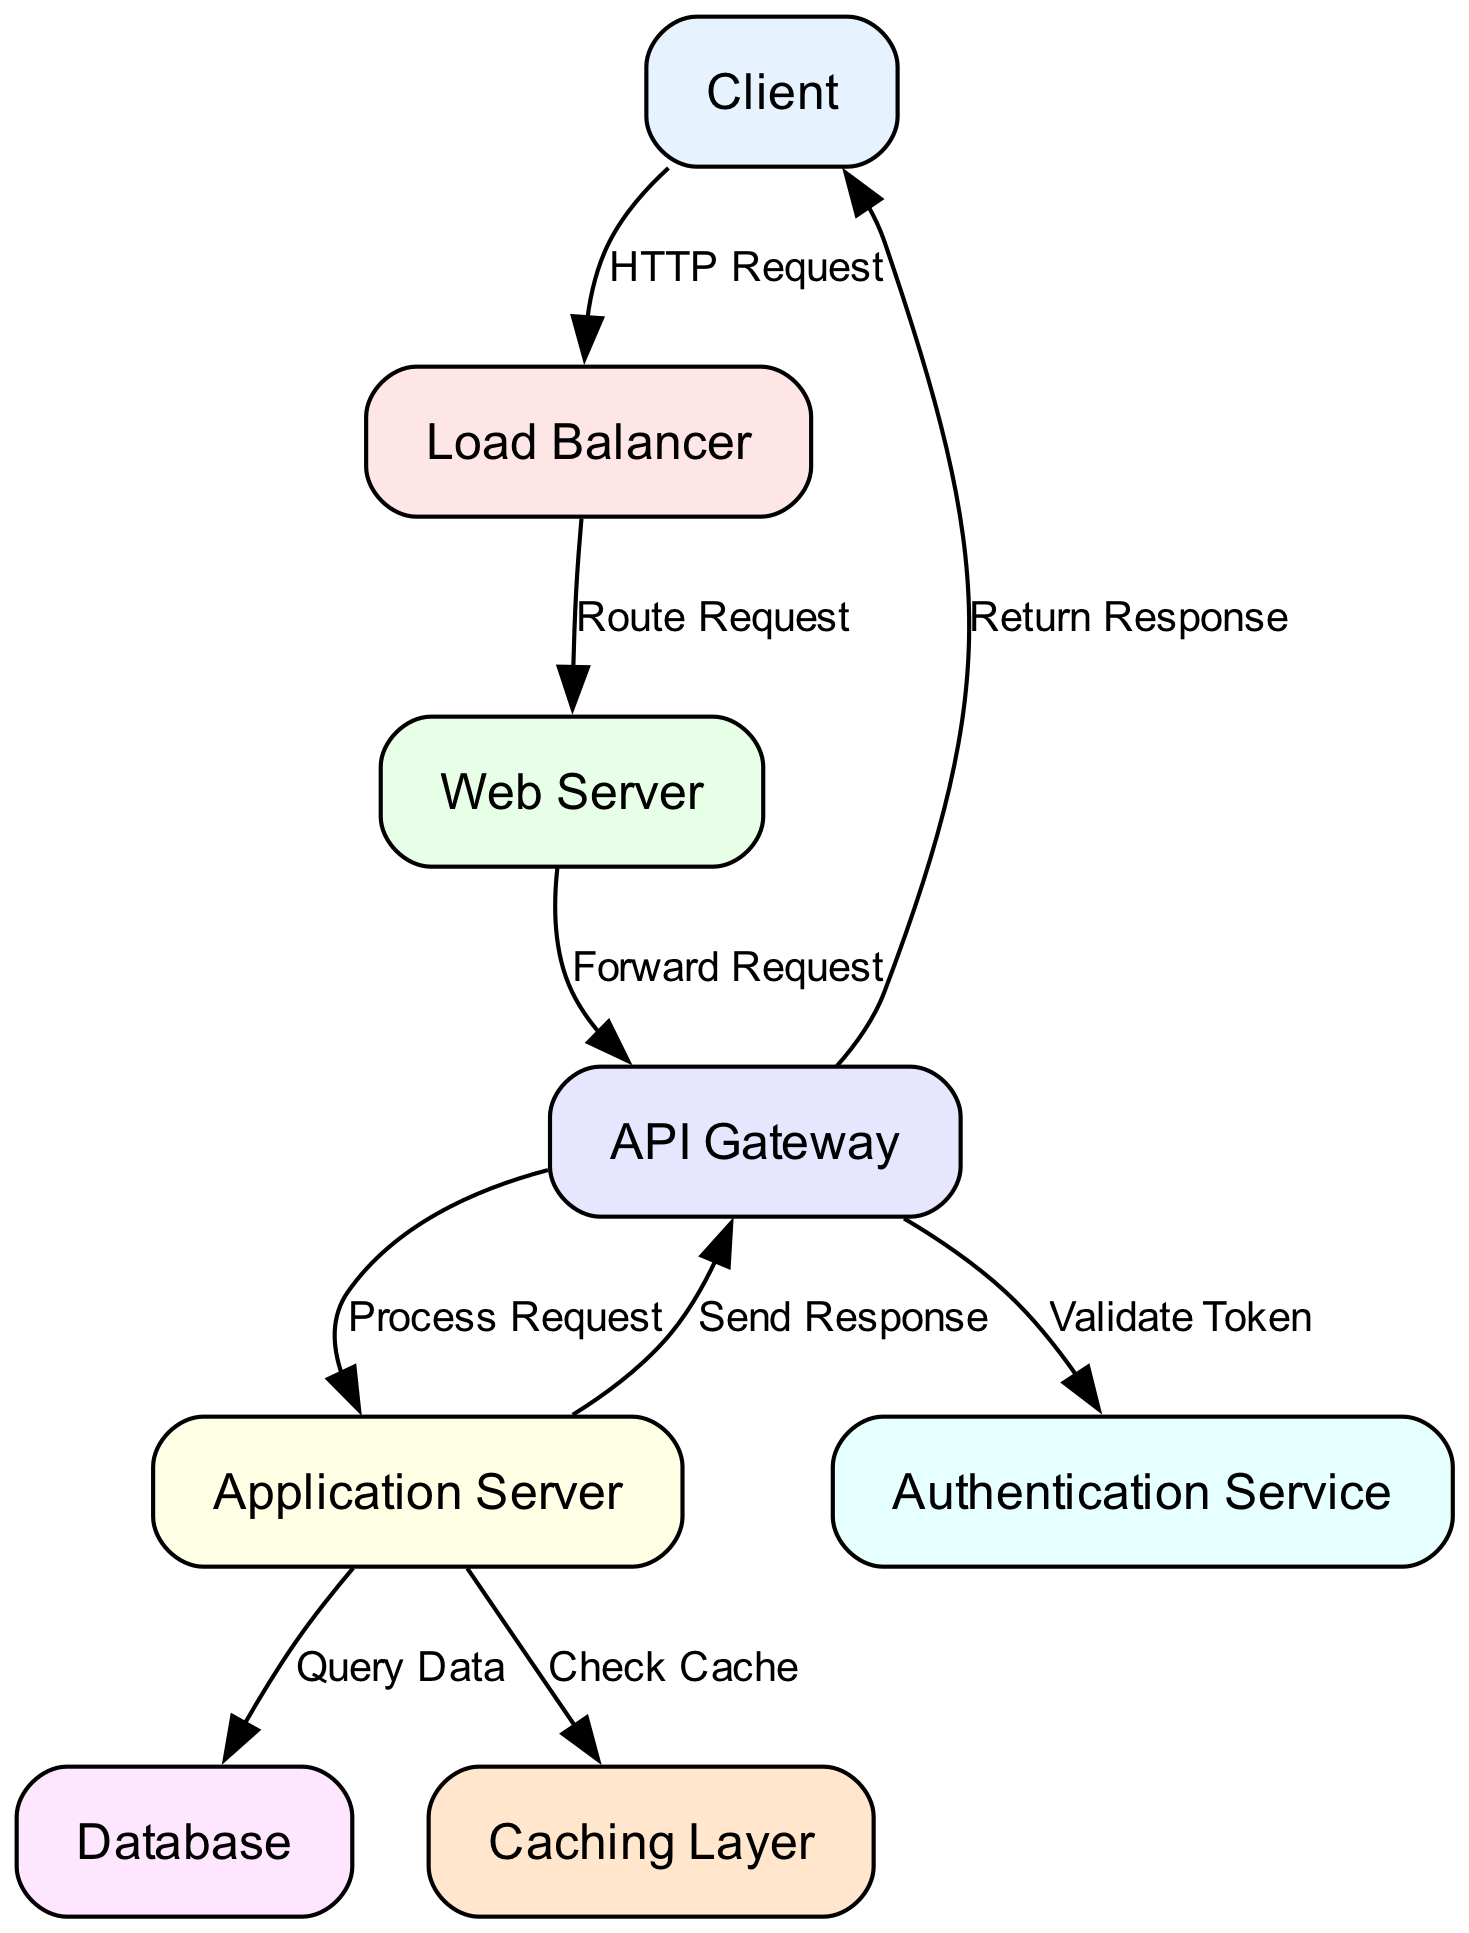What is the first node that receives the HTTP request? The diagram shows that the first node receiving the HTTP request from the Client is the Load Balancer. Therefore, the path starts from the Client to Load Balancer.
Answer: Load Balancer How many nodes are in the diagram? To determine the total number of nodes, we can count them: Client, Load Balancer, Web Server, Application Server, Database, Authentication Service, Caching Layer, and API Gateway, which totals to eight nodes.
Answer: Eight Which node sends the response back to the Client? The API Gateway is the node that sends the response back to the Client, as shown in the final directed edge connected to the Client from the API Gateway.
Answer: API Gateway What action does the Application Server take to gather information? The Application Server performs a "Query Data" action to gather information from the Database. This step is clearly depicted in the diagram showing a directed edge from Application Server to Database labeled "Query Data".
Answer: Query Data Which two nodes are responsible for validating the request? The API Gateway and the Authentication Service are involved in validating the request, as the API Gateway sends a request to the Authentication Service to "Validate Token" according to the flow depicted in the diagram.
Answer: API Gateway and Authentication Service What happens after the Application Server checks the cache? After checking the cache, if the necessary data is not present, the Application Server queries the Database as indicated by the directed edge "Query Data" following the "Check Cache" action in the diagram.
Answer: Query Data What is the relationship between the Web Server and the API Gateway? The relationship between the Web Server and the API Gateway is that the Web Server forwards the request to the API Gateway, as represented by the directed edge labeled "Forward Request".
Answer: Forward Request Which layer comes before the Application Server in the request flow? The Caching Layer comes before the Application Server in the request flow, as illustrated by the directed edge from Application Server to Caching Layer labeled "Check Cache".
Answer: Caching Layer 